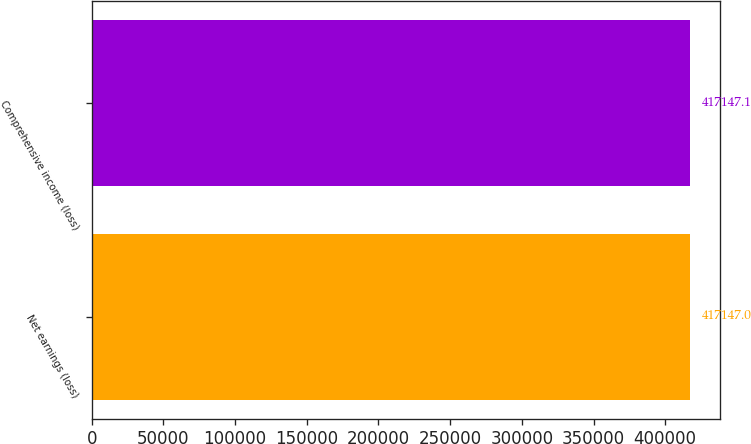Convert chart. <chart><loc_0><loc_0><loc_500><loc_500><bar_chart><fcel>Net earnings (loss)<fcel>Comprehensive income (loss)<nl><fcel>417147<fcel>417147<nl></chart> 